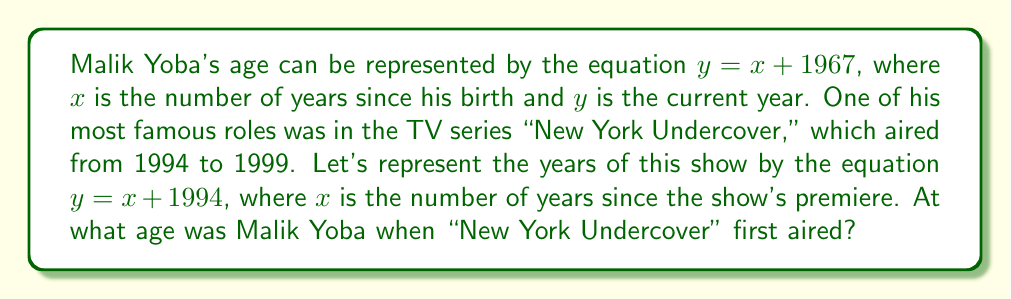Help me with this question. Let's solve this step-by-step:

1) We have two equations:
   $$y = x + 1967$$ (Malik Yoba's age)
   $$y = x + 1994$$ (Years since "New York Undercover" premiered)

2) To find the intersection, we set these equations equal to each other:
   $$x + 1967 = x + 1994$$

3) Subtract $x$ from both sides:
   $$1967 = 1994$$

4) Subtract 1967 from both sides:
   $$0 = 27$$

5) This equation is always true, which means the lines intersect when $x = 27$.

6) To find Malik Yoba's age when the show premiered, we substitute $x = 0$ into his age equation:
   $$y = 0 + 1994 = 1994$$

7) Now we can calculate his age:
   $$1994 - 1967 = 27$$

Therefore, Malik Yoba was 27 years old when "New York Undercover" first aired.
Answer: 27 years old 